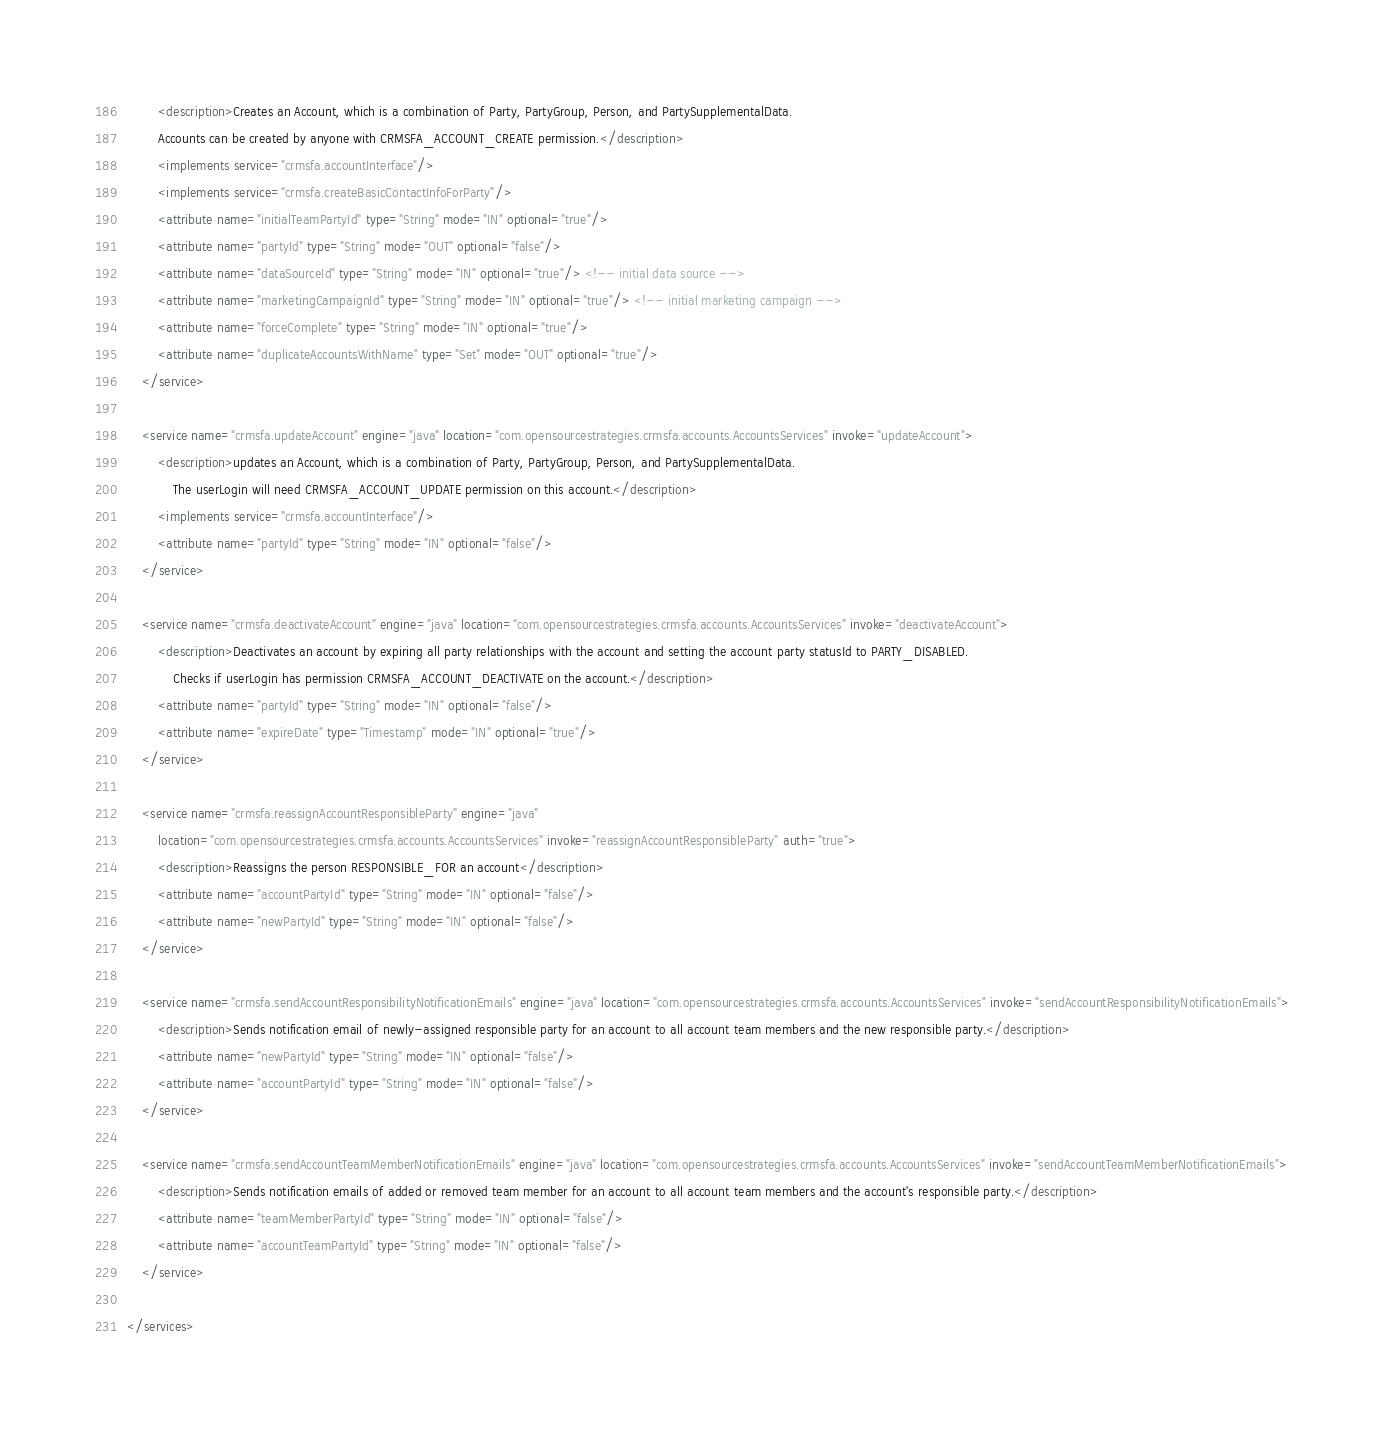Convert code to text. <code><loc_0><loc_0><loc_500><loc_500><_XML_>        <description>Creates an Account, which is a combination of Party, PartyGroup, Person, and PartySupplementalData.
        Accounts can be created by anyone with CRMSFA_ACCOUNT_CREATE permission.</description>
        <implements service="crmsfa.accountInterface"/>
        <implements service="crmsfa.createBasicContactInfoForParty"/> 
        <attribute name="initialTeamPartyId" type="String" mode="IN" optional="true"/>
        <attribute name="partyId" type="String" mode="OUT" optional="false"/>
        <attribute name="dataSourceId" type="String" mode="IN" optional="true"/> <!-- initial data source -->
        <attribute name="marketingCampaignId" type="String" mode="IN" optional="true"/> <!-- initial marketing campaign -->
        <attribute name="forceComplete" type="String" mode="IN" optional="true"/>
        <attribute name="duplicateAccountsWithName" type="Set" mode="OUT" optional="true"/>
    </service>

    <service name="crmsfa.updateAccount" engine="java" location="com.opensourcestrategies.crmsfa.accounts.AccountsServices" invoke="updateAccount">
        <description>updates an Account, which is a combination of Party, PartyGroup, Person, and PartySupplementalData. 
            The userLogin will need CRMSFA_ACCOUNT_UPDATE permission on this account.</description>
        <implements service="crmsfa.accountInterface"/>
        <attribute name="partyId" type="String" mode="IN" optional="false"/>
    </service>

    <service name="crmsfa.deactivateAccount" engine="java" location="com.opensourcestrategies.crmsfa.accounts.AccountsServices" invoke="deactivateAccount">
        <description>Deactivates an account by expiring all party relationships with the account and setting the account party statusId to PARTY_DISABLED. 
            Checks if userLogin has permission CRMSFA_ACCOUNT_DEACTIVATE on the account.</description>
        <attribute name="partyId" type="String" mode="IN" optional="false"/>
        <attribute name="expireDate" type="Timestamp" mode="IN" optional="true"/>
    </service>

    <service name="crmsfa.reassignAccountResponsibleParty" engine="java"
        location="com.opensourcestrategies.crmsfa.accounts.AccountsServices" invoke="reassignAccountResponsibleParty" auth="true">
        <description>Reassigns the person RESPONSIBLE_FOR an account</description>
        <attribute name="accountPartyId" type="String" mode="IN" optional="false"/>
        <attribute name="newPartyId" type="String" mode="IN" optional="false"/>
    </service>

    <service name="crmsfa.sendAccountResponsibilityNotificationEmails" engine="java" location="com.opensourcestrategies.crmsfa.accounts.AccountsServices" invoke="sendAccountResponsibilityNotificationEmails">
        <description>Sends notification email of newly-assigned responsible party for an account to all account team members and the new responsible party.</description>
        <attribute name="newPartyId" type="String" mode="IN" optional="false"/>
        <attribute name="accountPartyId" type="String" mode="IN" optional="false"/>
    </service>
    
    <service name="crmsfa.sendAccountTeamMemberNotificationEmails" engine="java" location="com.opensourcestrategies.crmsfa.accounts.AccountsServices" invoke="sendAccountTeamMemberNotificationEmails">
        <description>Sends notification emails of added or removed team member for an account to all account team members and the account's responsible party.</description>
        <attribute name="teamMemberPartyId" type="String" mode="IN" optional="false"/>
        <attribute name="accountTeamPartyId" type="String" mode="IN" optional="false"/>
    </service>
    
</services>

</code> 